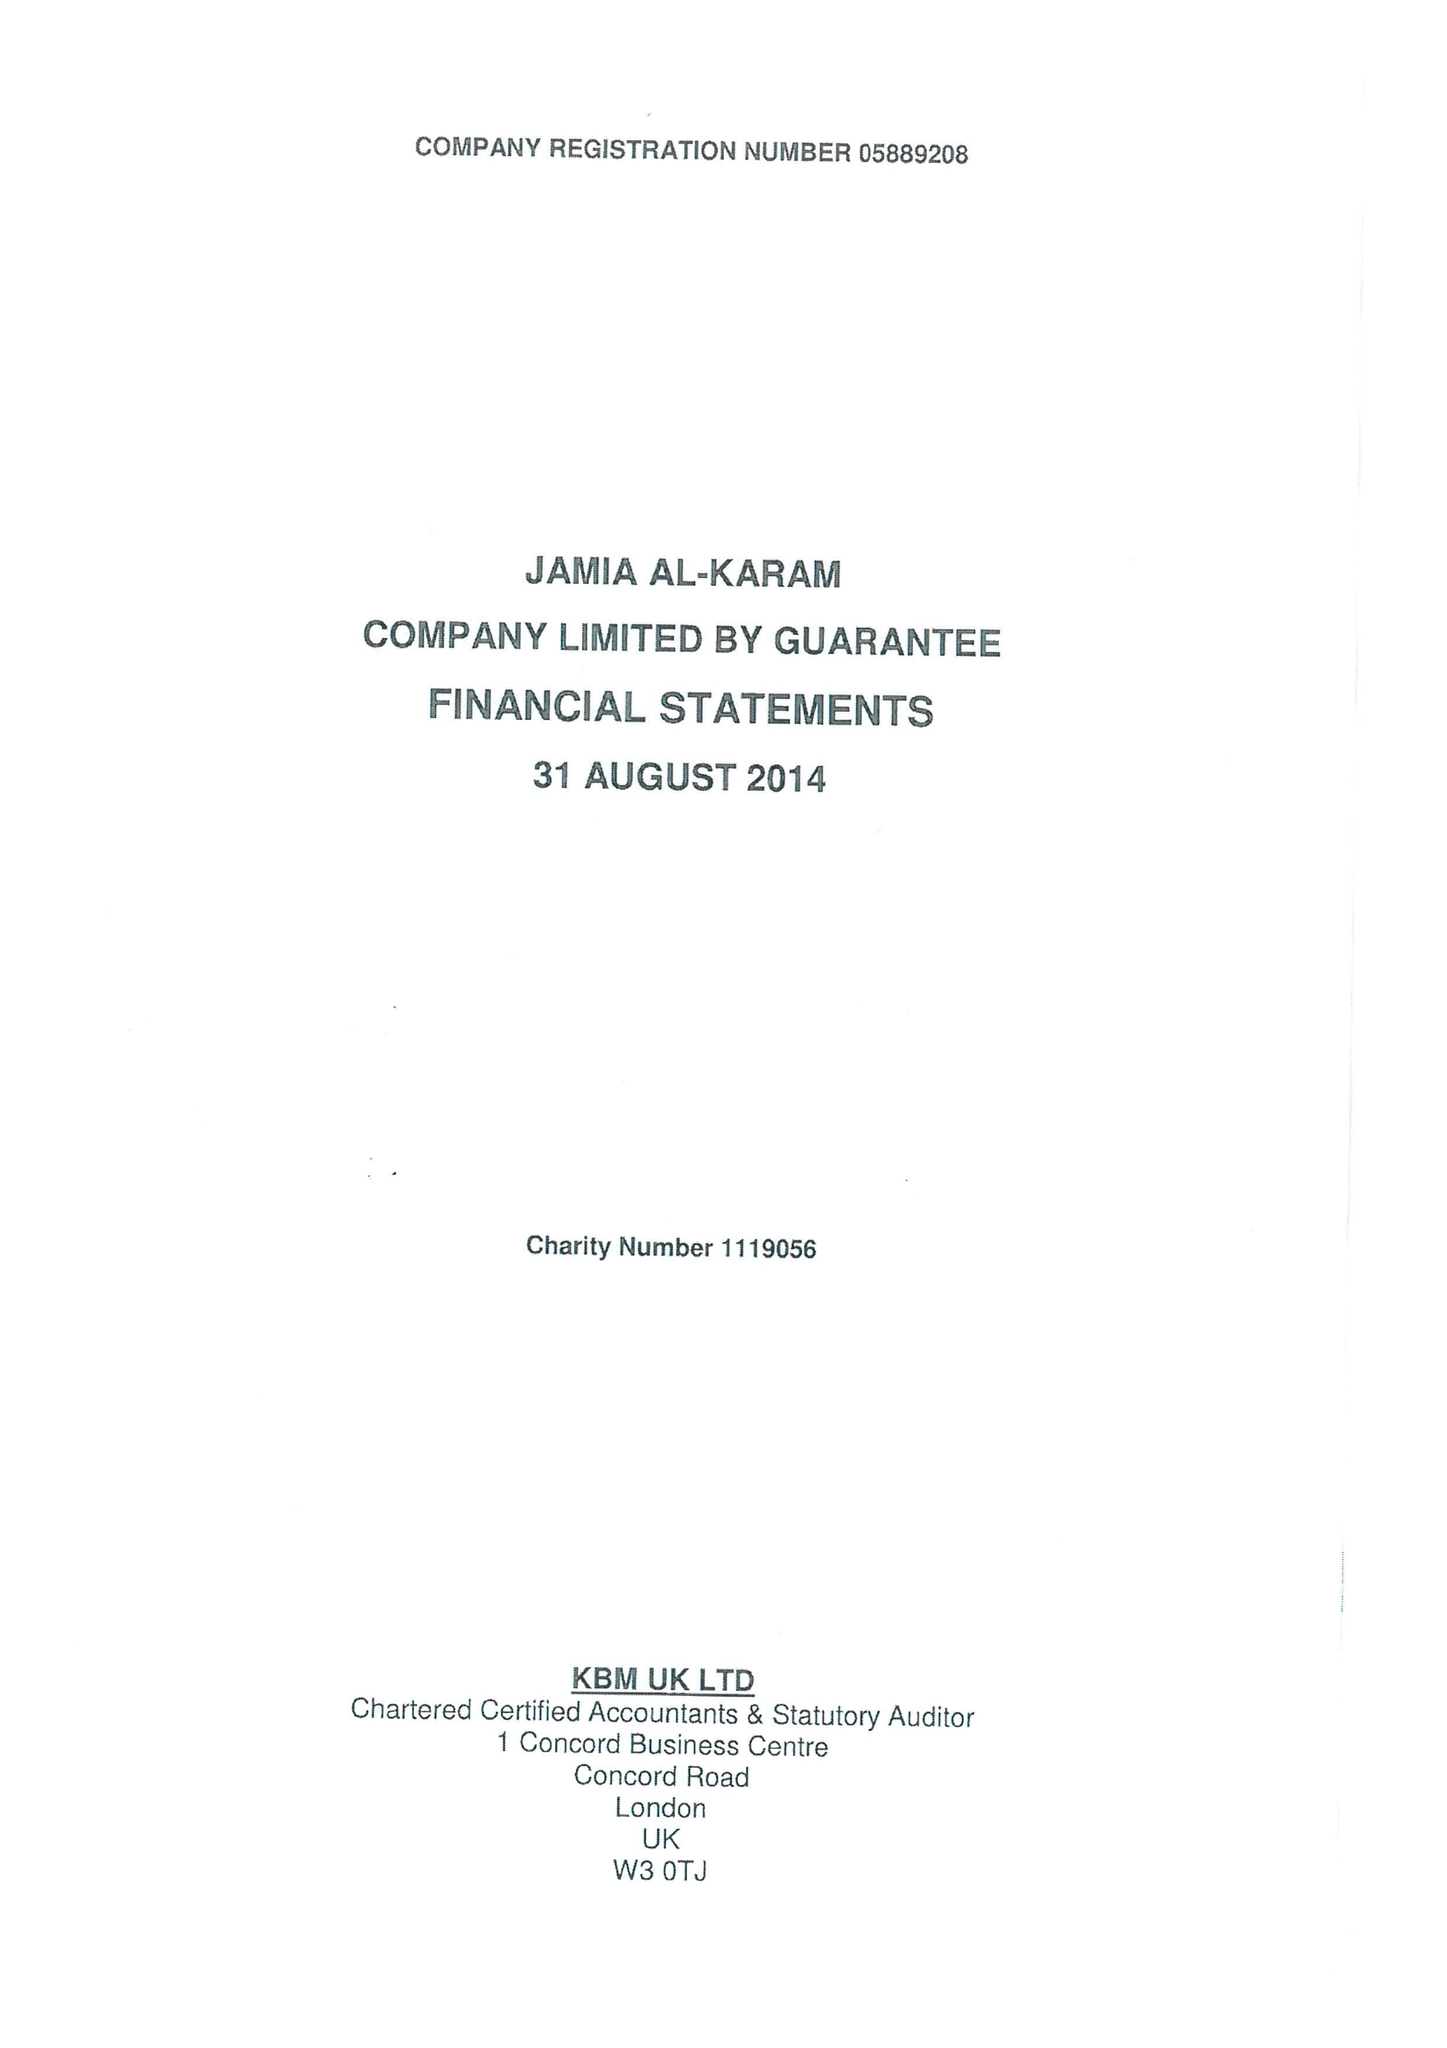What is the value for the address__post_town?
Answer the question using a single word or phrase. RETFORD 